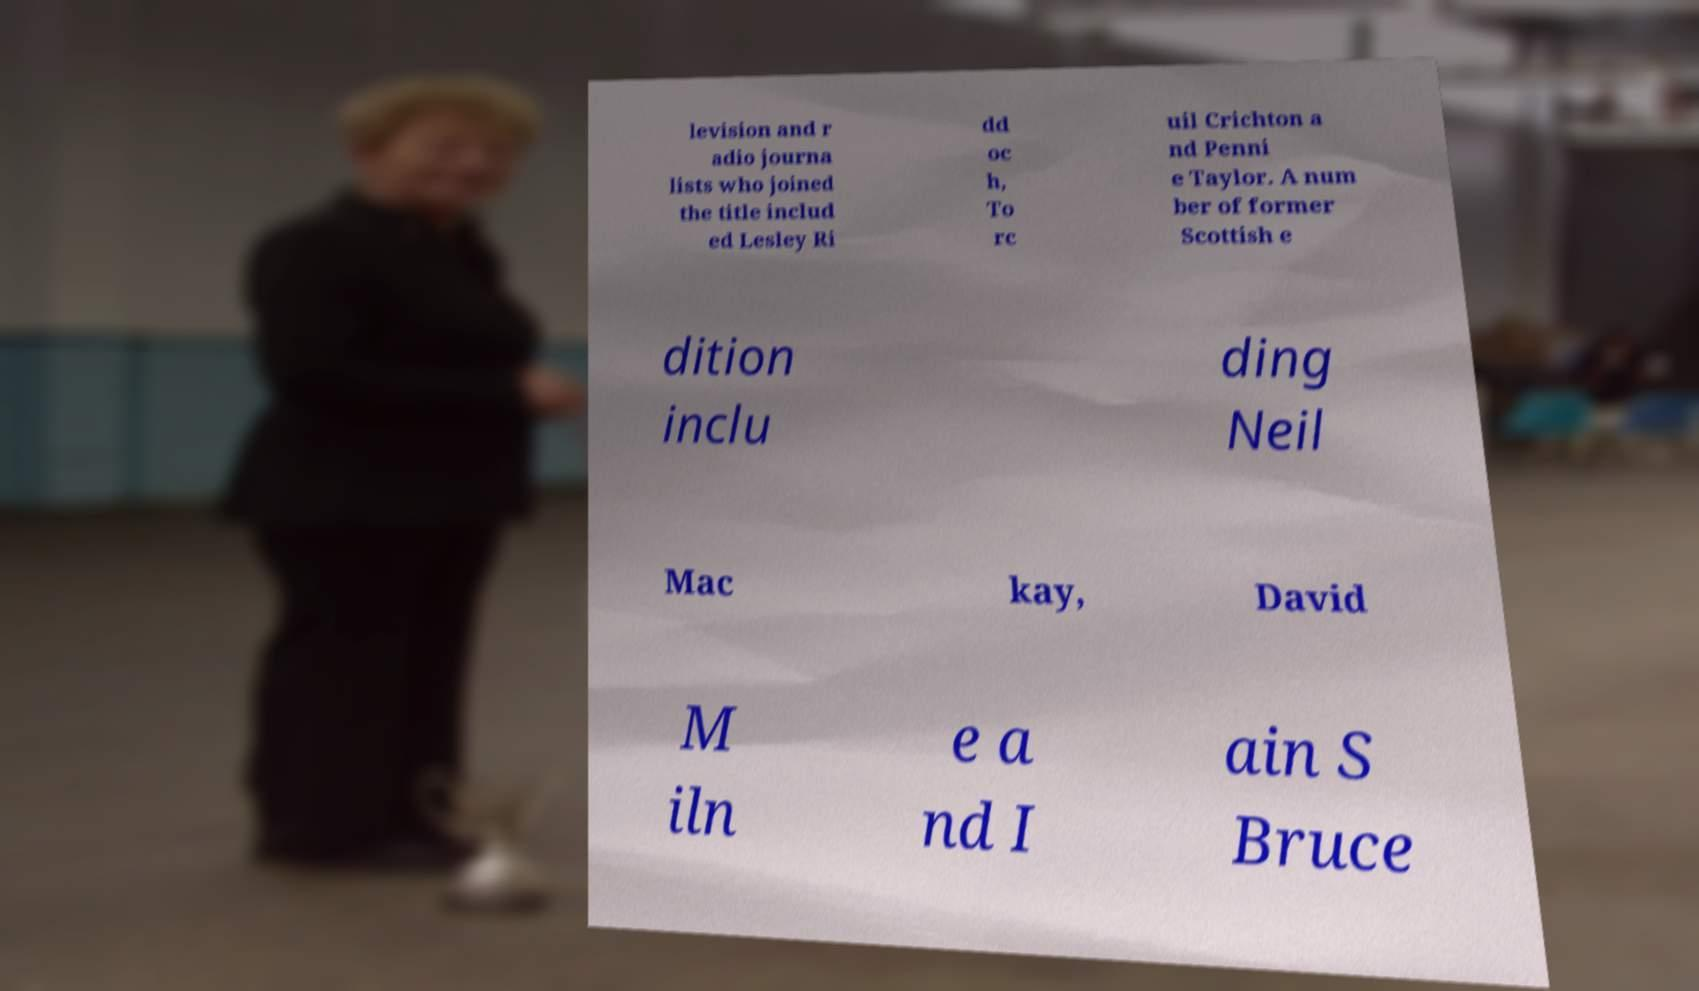Could you assist in decoding the text presented in this image and type it out clearly? levision and r adio journa lists who joined the title includ ed Lesley Ri dd oc h, To rc uil Crichton a nd Penni e Taylor. A num ber of former Scottish e dition inclu ding Neil Mac kay, David M iln e a nd I ain S Bruce 